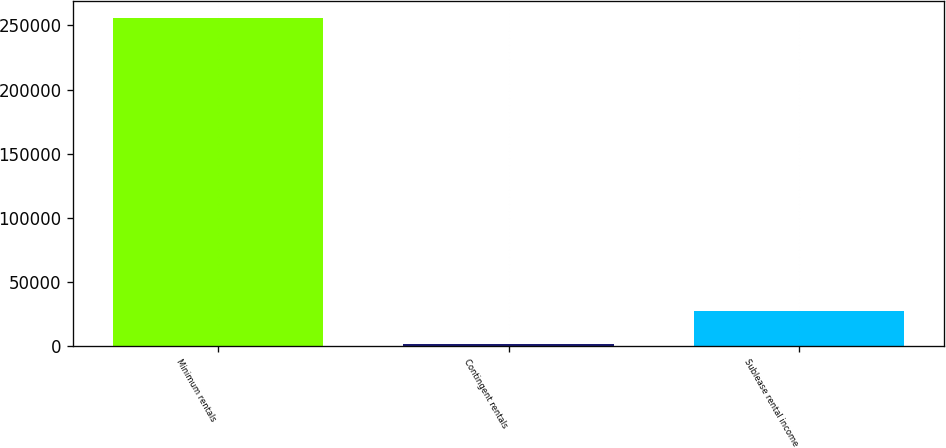Convert chart. <chart><loc_0><loc_0><loc_500><loc_500><bar_chart><fcel>Minimum rentals<fcel>Contingent rentals<fcel>Sublease rental income<nl><fcel>255955<fcel>1811<fcel>27225.4<nl></chart> 